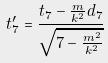Convert formula to latex. <formula><loc_0><loc_0><loc_500><loc_500>t _ { 7 } ^ { \prime } = \frac { t _ { 7 } - \frac { m } { k ^ { 2 } } d _ { 7 } } { \sqrt { 7 - \frac { m ^ { 2 } } { k ^ { 2 } } } }</formula> 